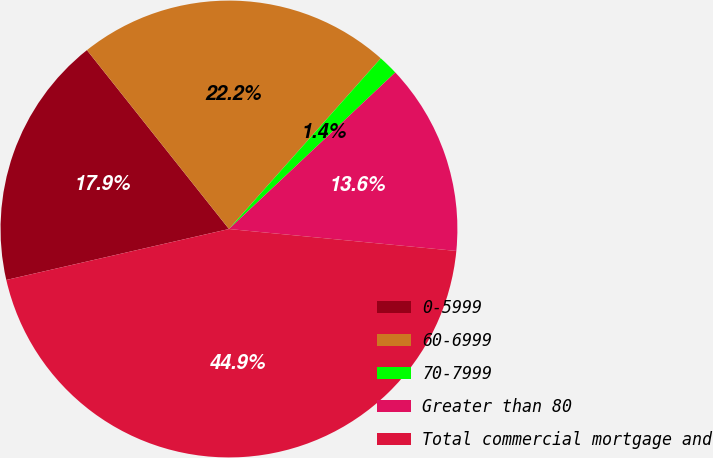Convert chart. <chart><loc_0><loc_0><loc_500><loc_500><pie_chart><fcel>0-5999<fcel>60-6999<fcel>70-7999<fcel>Greater than 80<fcel>Total commercial mortgage and<nl><fcel>17.9%<fcel>22.25%<fcel>1.41%<fcel>13.55%<fcel>44.89%<nl></chart> 